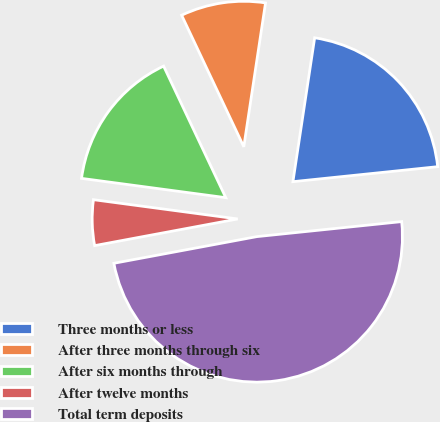Convert chart to OTSL. <chart><loc_0><loc_0><loc_500><loc_500><pie_chart><fcel>Three months or less<fcel>After three months through six<fcel>After six months through<fcel>After twelve months<fcel>Total term deposits<nl><fcel>20.97%<fcel>9.41%<fcel>15.86%<fcel>5.05%<fcel>48.71%<nl></chart> 